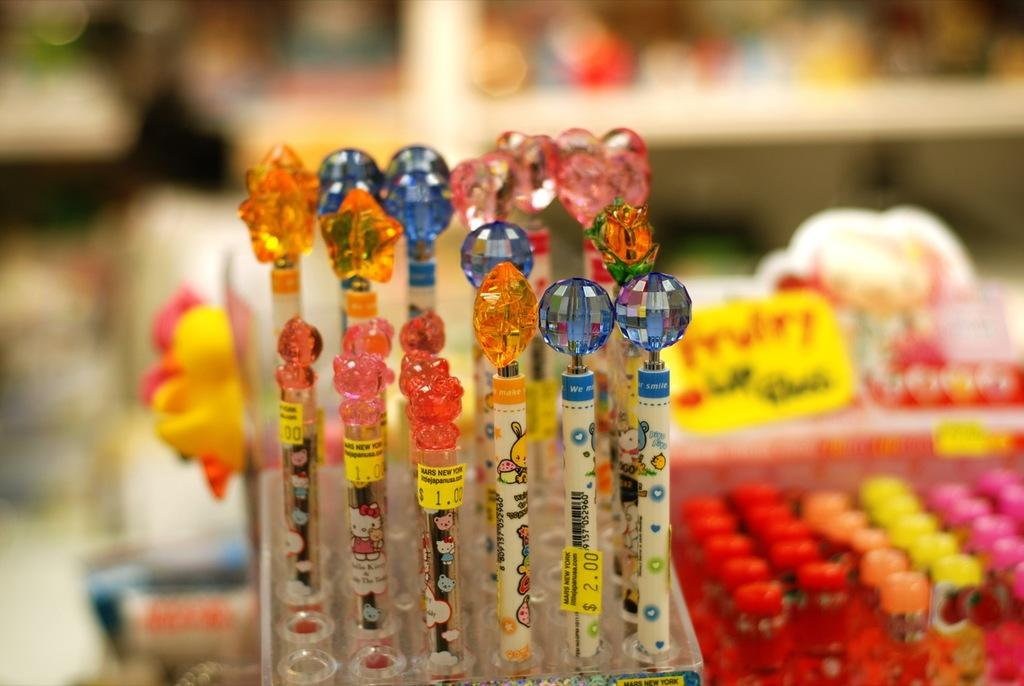What items are present in the image that have stickers on them? There are pens with stickers in the image. What other objects can be seen in the image besides the pens with stickers? There are other objects in the image, but their specific details are not mentioned in the provided facts. Can you describe the background of the image? The background of the image is blurred. What type of quartz can be seen in the image? There is no quartz present in the image. What is the manager doing in the image? There is no mention of a manager or any person in the image. 